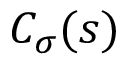Convert formula to latex. <formula><loc_0><loc_0><loc_500><loc_500>C _ { \sigma } ( s )</formula> 